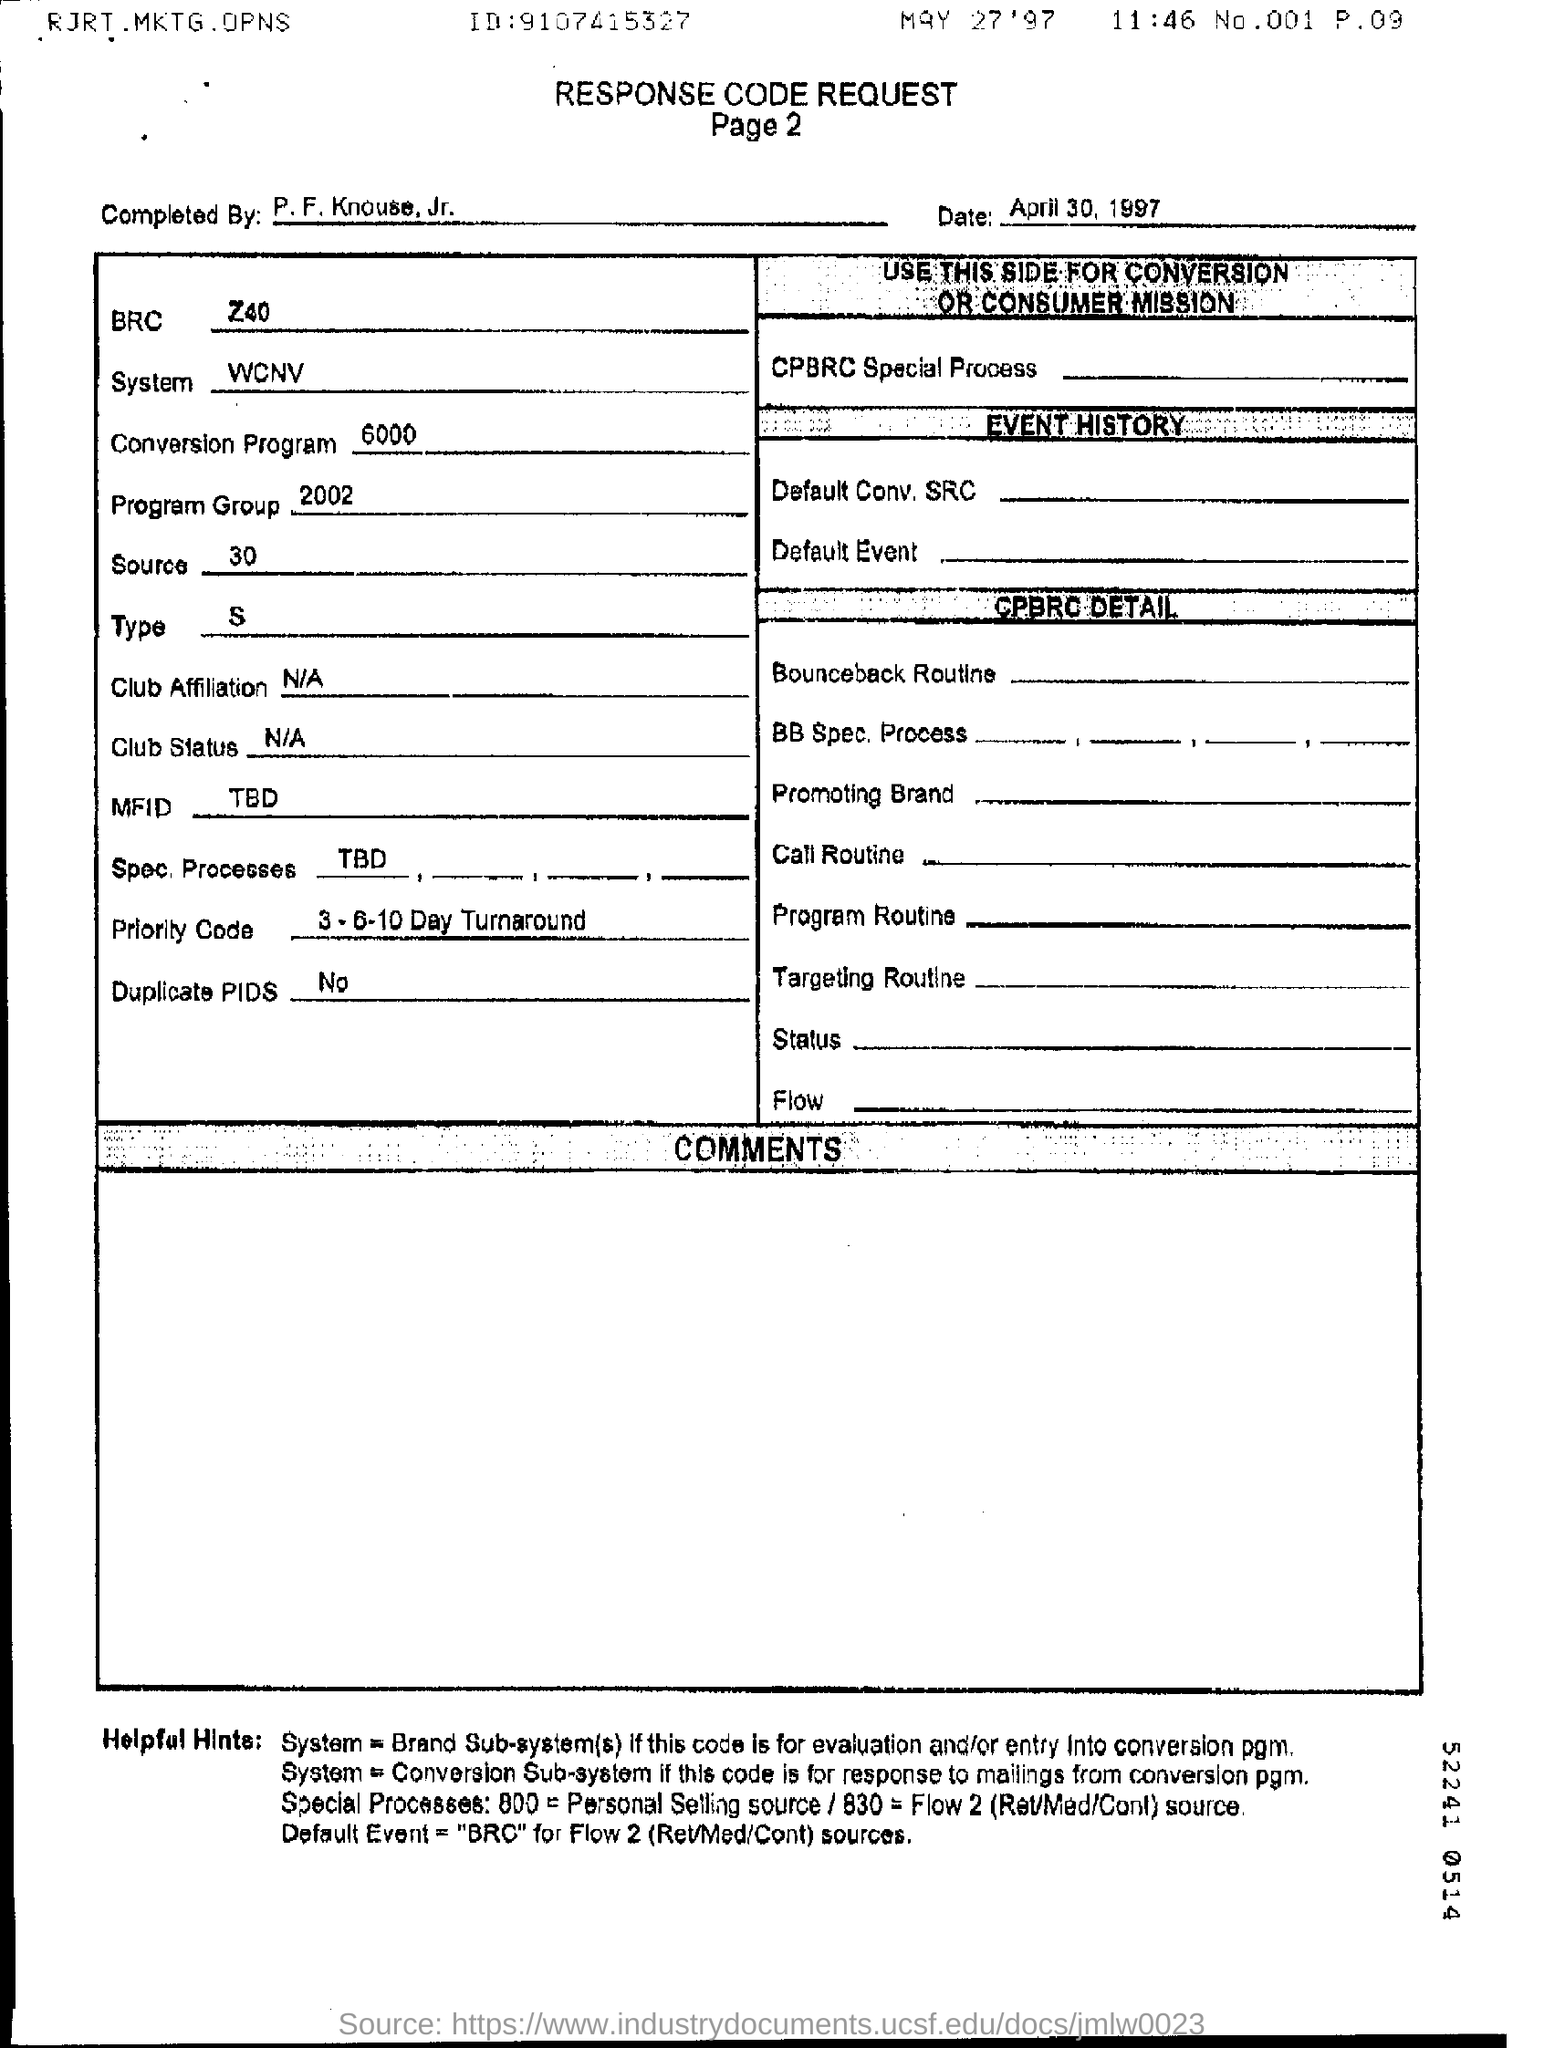Who is it completed by?
Your response must be concise. P. F. Knouse, Jr. What is the date?
Your response must be concise. MAY 27 ' 97. What is the BRC?
Your answer should be very brief. Z40. What is the system?
Provide a succinct answer. WCNV. What is the conversion program?
Your response must be concise. 6000. What is the program group?
Provide a short and direct response. 2002. What is the source?
Your answer should be compact. 30. What is the type?
Your response must be concise. S. What is the Priority code?
Your response must be concise. 3-6-10 Day Turnaround. What is the Duplicate PIDS?
Make the answer very short. No. 